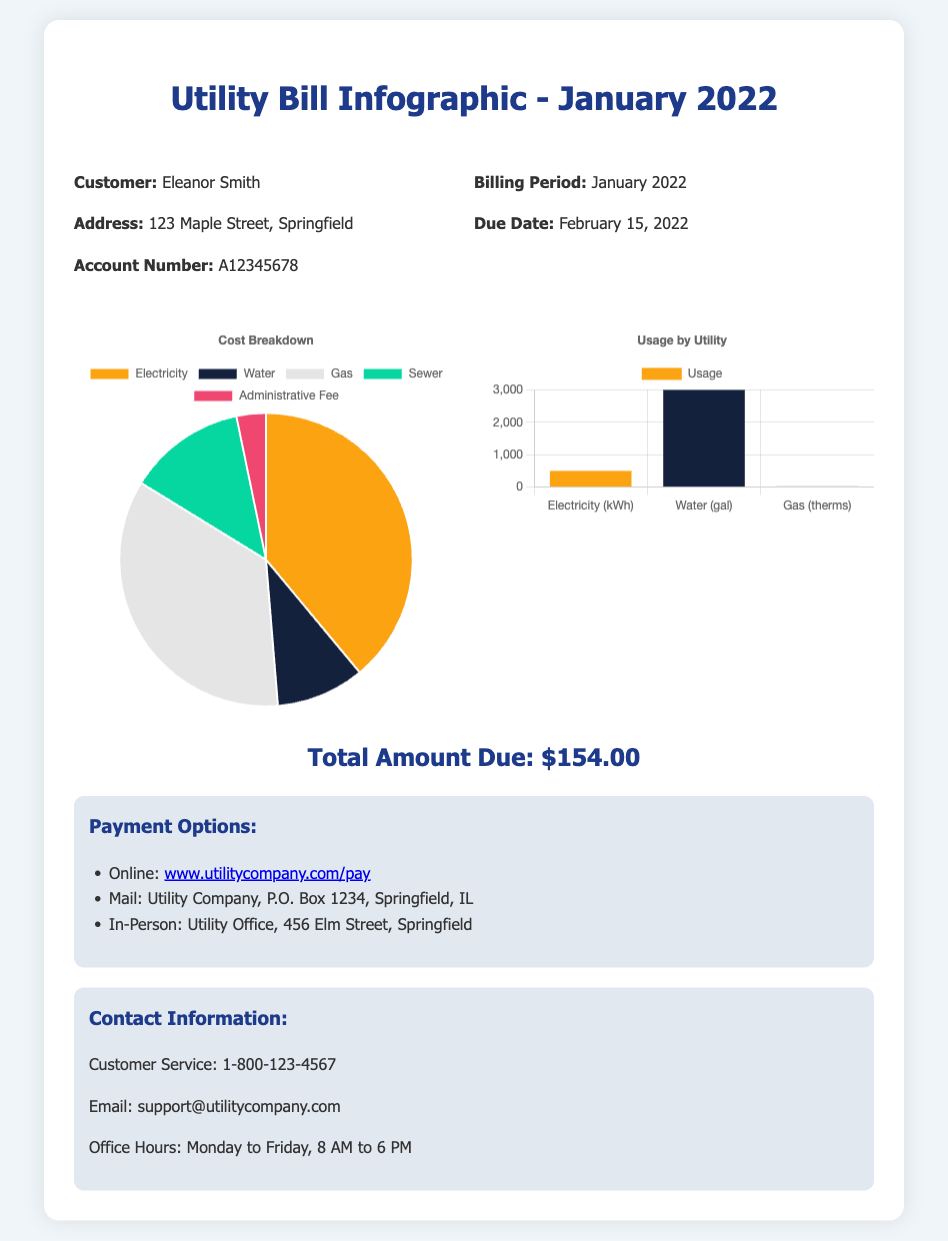What is the name of the customer? The name of the customer is specified in the document as Eleanor Smith.
Answer: Eleanor Smith What is the total amount due? The total amount due is clearly stated in the document and amounts to $154.00.
Answer: $154.00 What is the billing period? The billing period is mentioned in the document and is January 2022.
Answer: January 2022 What are the office hours for customer service? The office hours for customer service are provided in the document as Monday to Friday, 8 AM to 6 PM.
Answer: Monday to Friday, 8 AM to 6 PM How much was charged for electricity? The cost breakdown shows that the charge for electricity is $60.
Answer: $60 What is the main utility used in kilowatt hours? The main utility used is electricity, which is measured in kilowatt hours.
Answer: Electricity (kWh) Which utility has the highest charge? By comparing the cost breakdown, electricity has the highest charge of $60.
Answer: Electricity How can payments be made? Payment options include online, by mail, or in-person.
Answer: Online, Mail, In-Person What is the most used utility measured in gallons? The most used utility in gallons is water, with a usage of 3000 gallons.
Answer: 3000 gallons 